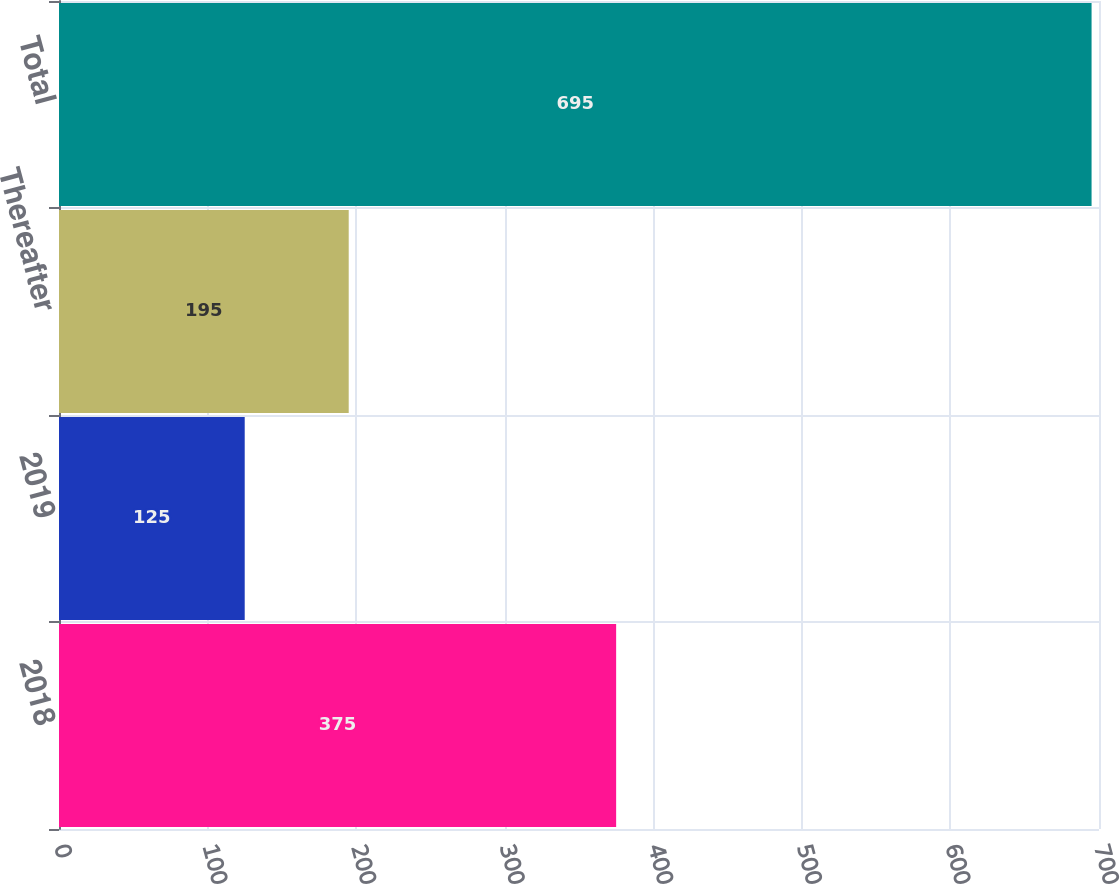Convert chart to OTSL. <chart><loc_0><loc_0><loc_500><loc_500><bar_chart><fcel>2018<fcel>2019<fcel>Thereafter<fcel>Total<nl><fcel>375<fcel>125<fcel>195<fcel>695<nl></chart> 